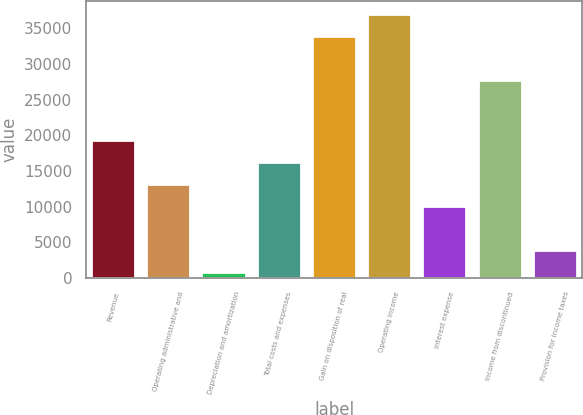Convert chart to OTSL. <chart><loc_0><loc_0><loc_500><loc_500><bar_chart><fcel>Revenue<fcel>Operating administrative and<fcel>Depreciation and amortization<fcel>Total costs and expenses<fcel>Gain on disposition of real<fcel>Operating income<fcel>Interest expense<fcel>Income from discontinued<fcel>Provision for income taxes<nl><fcel>19352.8<fcel>13195.2<fcel>880<fcel>16274<fcel>33924.4<fcel>37003.2<fcel>10116.4<fcel>27766.8<fcel>3958.8<nl></chart> 